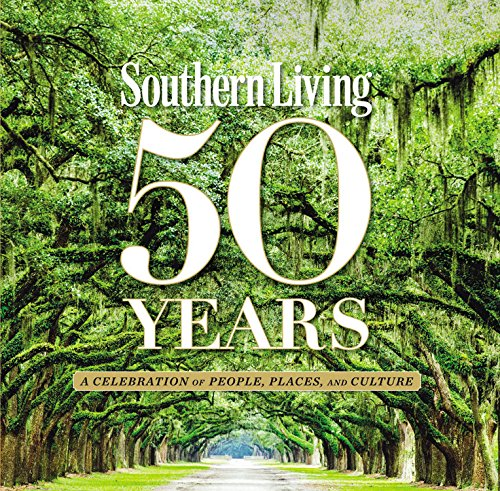Is this a recipe book? Yes, it primarily functions as a recipe book, enriched with diverse and authentic Southern recipes that celebrate traditional cooking and regional flavors. 